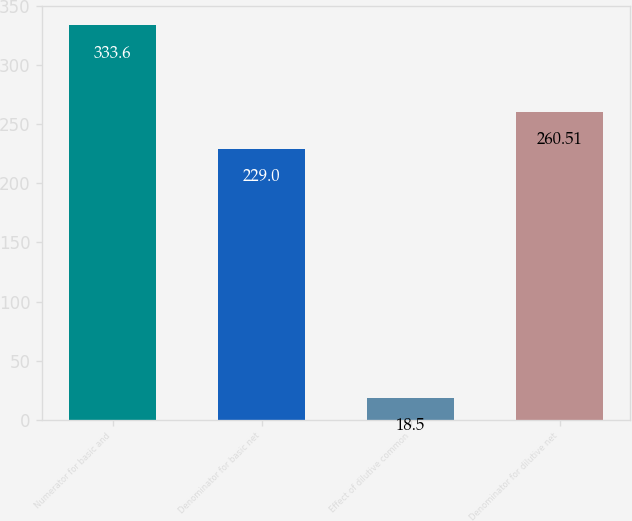<chart> <loc_0><loc_0><loc_500><loc_500><bar_chart><fcel>Numerator for basic and<fcel>Denominator for basic net<fcel>Effect of dilutive common<fcel>Denominator for dilutive net<nl><fcel>333.6<fcel>229<fcel>18.5<fcel>260.51<nl></chart> 